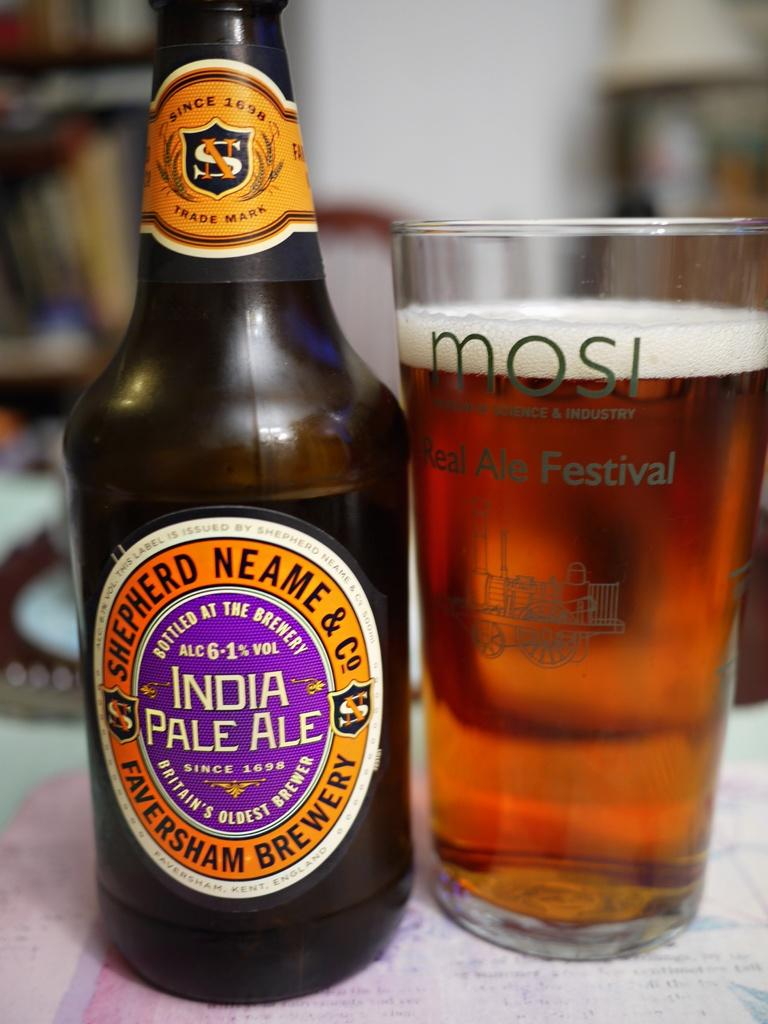What type of beverage container is present in the image? There is a wine bottle in the image. What is used for drinking the wine in the image? There is a wine glass in the image. Where are the wine bottle and wine glass placed? The wine bottle and wine glass are placed on a surface. How would you describe the background of the image? The background of the image is blurred. What type of clothing does the boy have a zipper on in the image? There is no boy present in the image, nor is there any clothing with a zipper mentioned. 